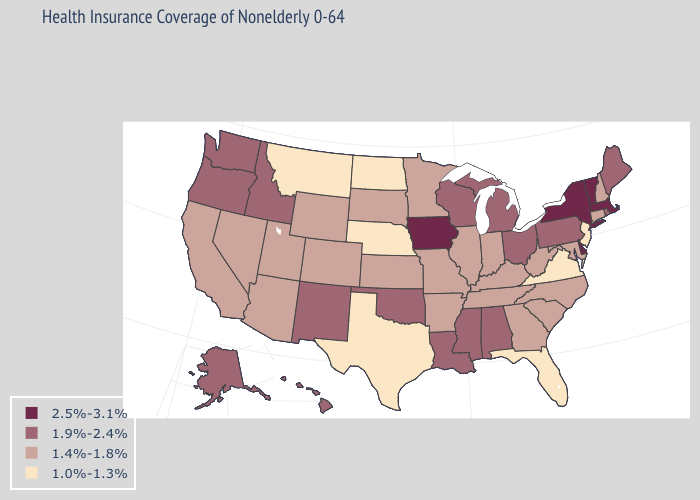How many symbols are there in the legend?
Concise answer only. 4. Does the first symbol in the legend represent the smallest category?
Write a very short answer. No. Does Delaware have the highest value in the South?
Keep it brief. Yes. What is the value of Wyoming?
Keep it brief. 1.4%-1.8%. Which states have the lowest value in the West?
Write a very short answer. Montana. What is the value of New Mexico?
Be succinct. 1.9%-2.4%. Name the states that have a value in the range 1.0%-1.3%?
Give a very brief answer. Florida, Montana, Nebraska, New Jersey, North Dakota, Texas, Virginia. How many symbols are there in the legend?
Give a very brief answer. 4. Among the states that border Iowa , does Wisconsin have the highest value?
Write a very short answer. Yes. What is the lowest value in the Northeast?
Be succinct. 1.0%-1.3%. Does the first symbol in the legend represent the smallest category?
Short answer required. No. Does Oklahoma have the same value as Alabama?
Short answer required. Yes. Name the states that have a value in the range 2.5%-3.1%?
Be succinct. Delaware, Iowa, Massachusetts, New York, Vermont. Does Alabama have the lowest value in the South?
Be succinct. No. Does Vermont have the highest value in the USA?
Quick response, please. Yes. 